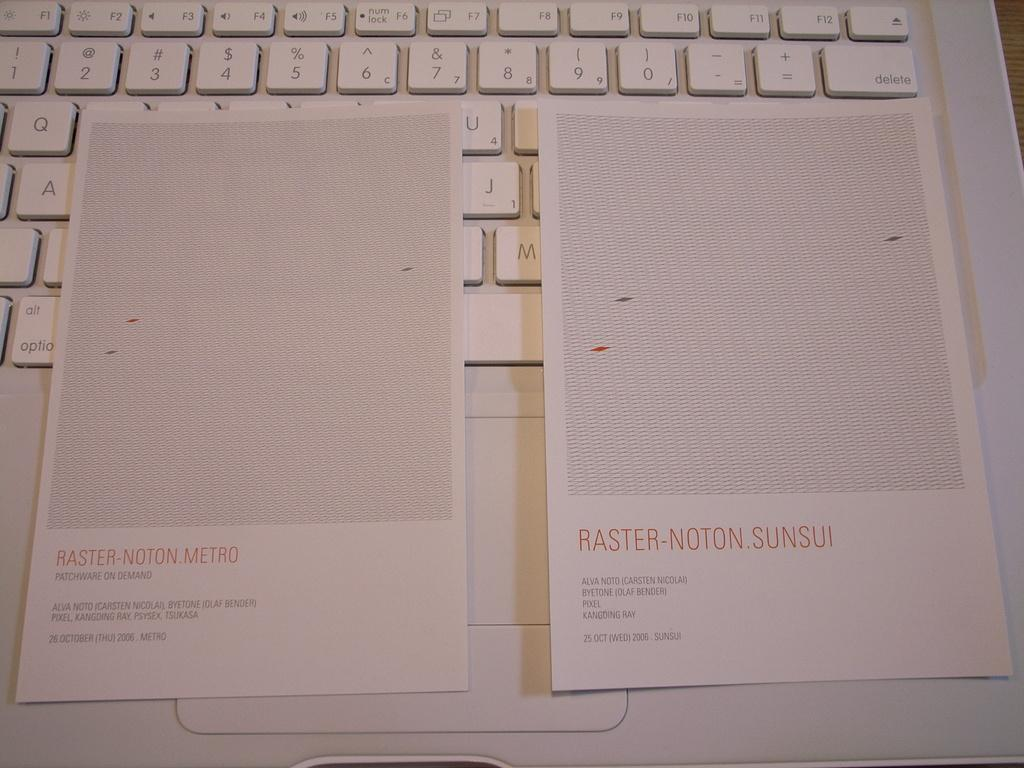<image>
Give a short and clear explanation of the subsequent image. Two pieces of paper, one the reads, "Raster-Noton.Metro sit on top of a white computer keyboard. 